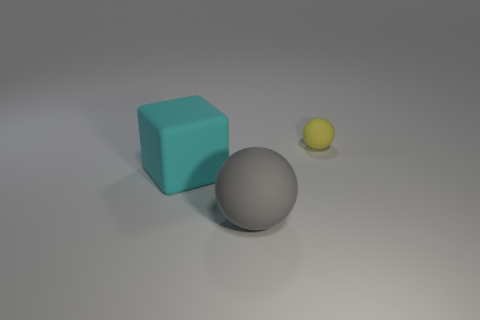Add 2 big matte blocks. How many objects exist? 5 Subtract all cubes. How many objects are left? 2 Subtract all gray cylinders. Subtract all large cyan cubes. How many objects are left? 2 Add 1 small rubber objects. How many small rubber objects are left? 2 Add 2 small matte cylinders. How many small matte cylinders exist? 2 Subtract 0 blue cubes. How many objects are left? 3 